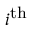Convert formula to latex. <formula><loc_0><loc_0><loc_500><loc_500>i ^ { t h }</formula> 